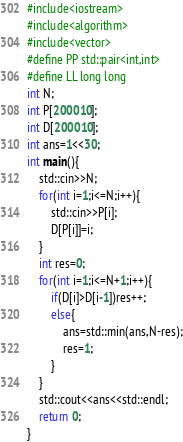<code> <loc_0><loc_0><loc_500><loc_500><_C++_>#include<iostream>
#include<algorithm>
#include<vector>
#define PP std::pair<int,int>
#define LL long long
int N;
int P[200010];
int D[200010];
int ans=1<<30;
int main(){
    std::cin>>N;
    for(int i=1;i<=N;i++){
        std::cin>>P[i];
        D[P[i]]=i;
    }
    int res=0;
    for(int i=1;i<=N+1;i++){
        if(D[i]>D[i-1])res++;
        else{
            ans=std::min(ans,N-res);
            res=1;
        }
    }
    std::cout<<ans<<std::endl;
    return 0;
}
</code> 